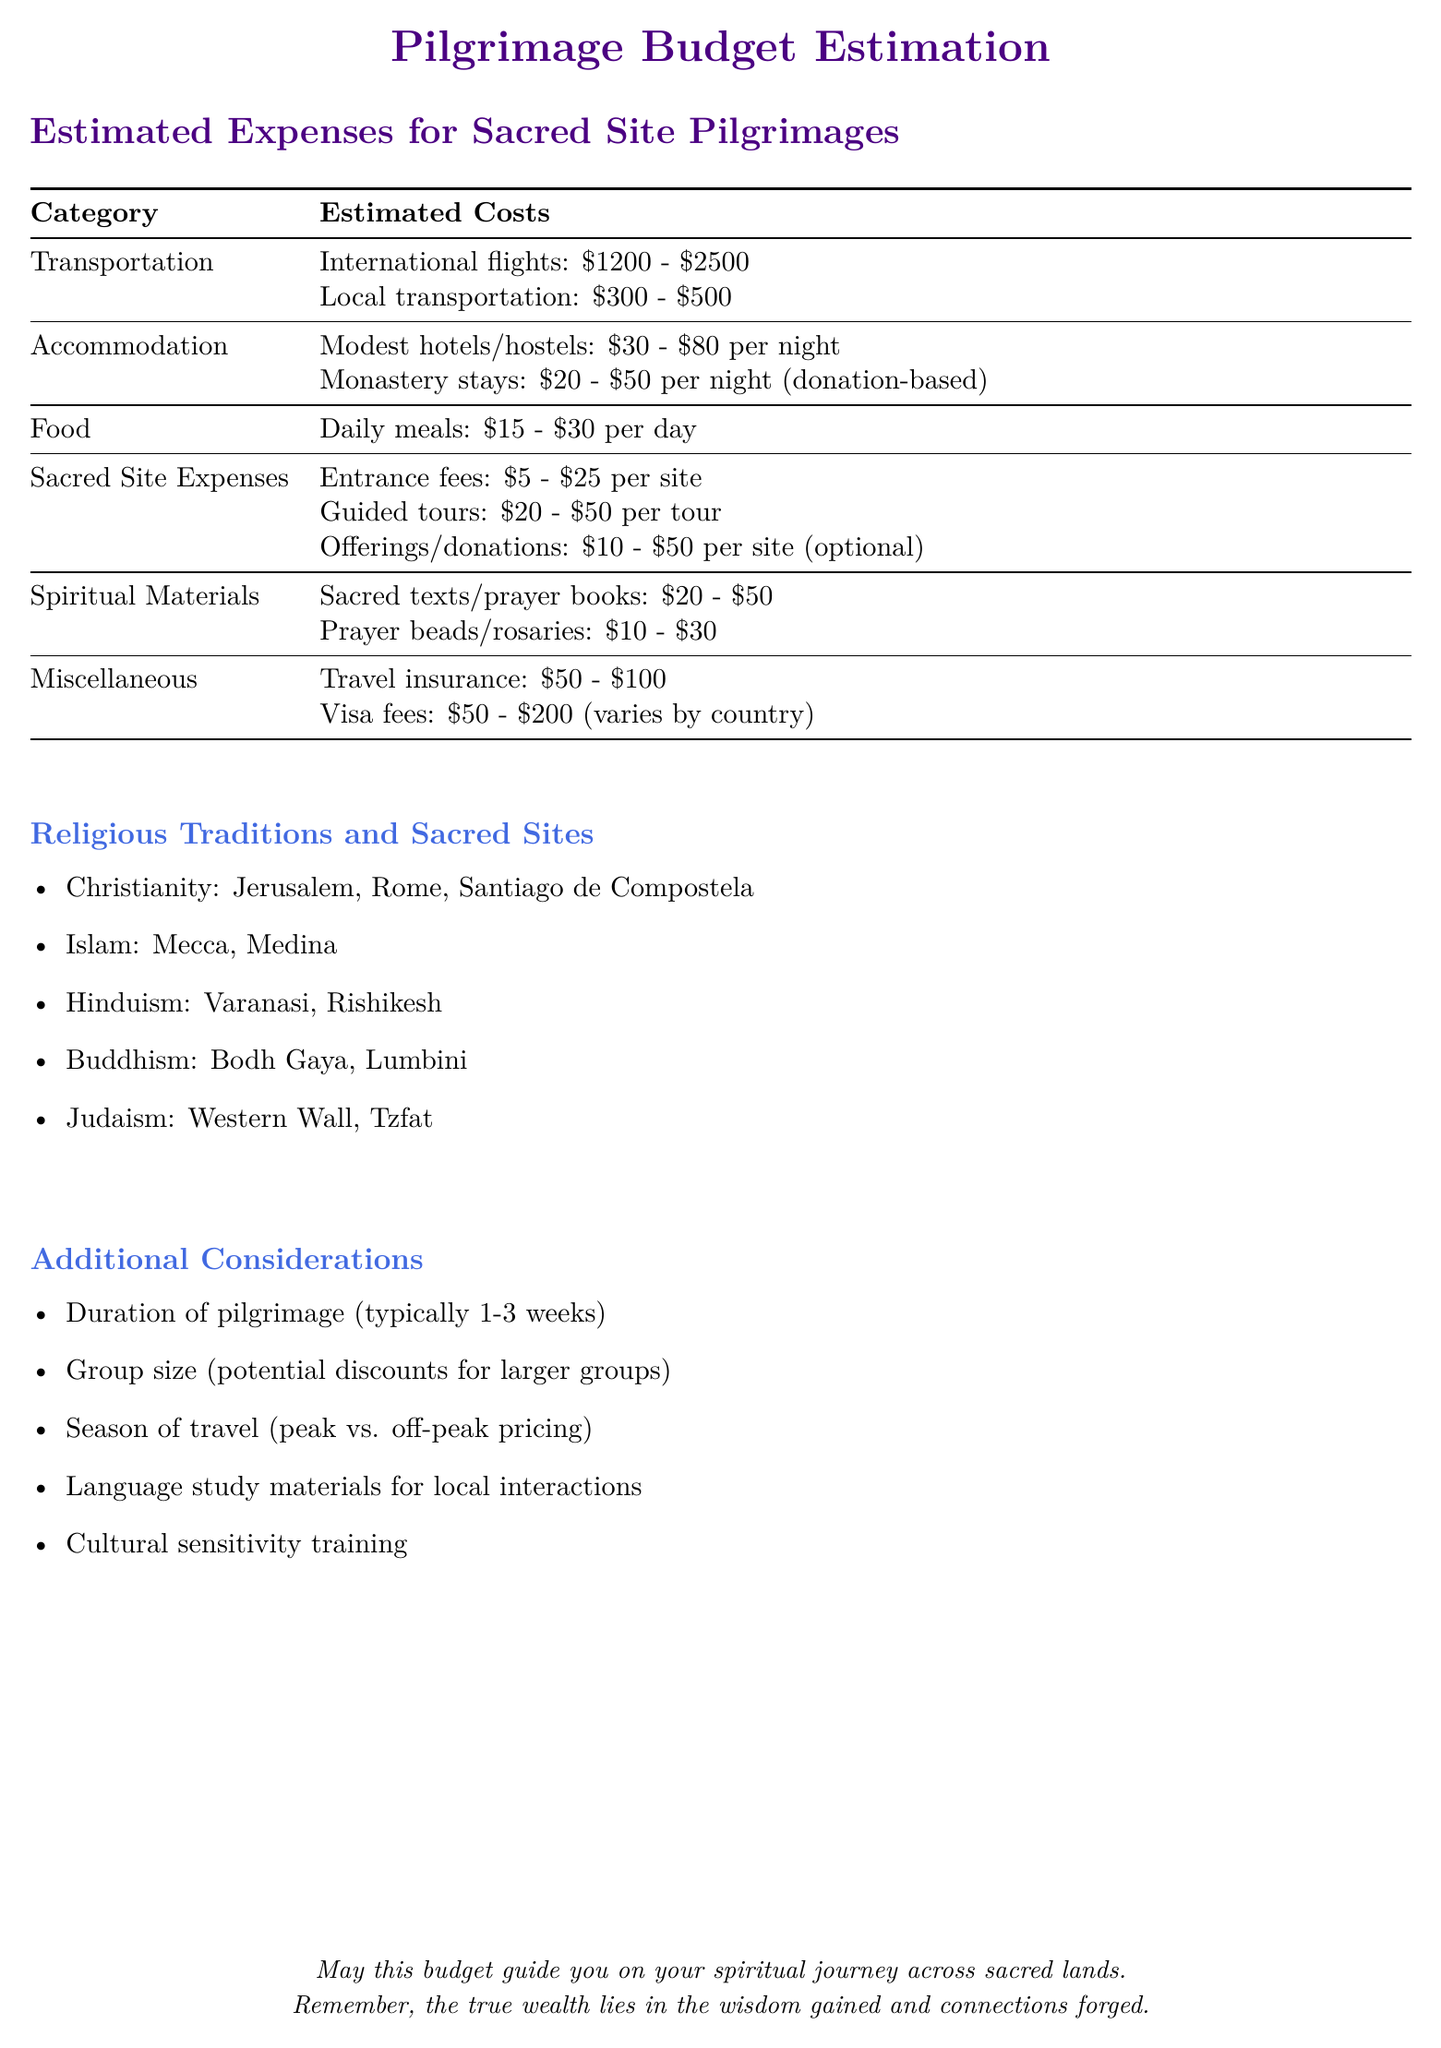What is the estimated cost for international flights? The document provides a range for international flights which is $1200 - $2500.
Answer: $1200 - $2500 What is the estimated cost of daily meals? The budget outlines the cost for daily meals, which is $15 - $30 per day.
Answer: $15 - $30 What is the donation-based cost for monastery stays? The document indicates that monastery stays range from $20 - $50 per night and are donation-based.
Answer: $20 - $50 What are two sacred sites for Buddhism listed in the document? The document lists Bodh Gaya and Lumbini as sacred sites for Buddhism.
Answer: Bodh Gaya, Lumbini How much can one expect to pay for a guided tour? The estimated cost for guided tours ranges from $20 - $50 per tour.
Answer: $20 - $50 What additional cost might be incurred based on the country visited? Visa fees are mentioned as an additional cost, which varies by country and is between $50 - $200.
Answer: $50 - $200 How does group size affect expenses? The document notes that there are potential discounts for larger groups, which suggests group size can influence expenses.
Answer: Discounts What is one additional consideration mentioned in the budget? The document lists various additional considerations such as the duration of pilgrimage or season of travel.
Answer: Duration of pilgrimage What type of spiritual materials are suggested to be included in the budget? The budget suggests including sacred texts/prayer books and prayer beads/rosaries as spiritual materials.
Answer: Sacred texts, prayer beads 